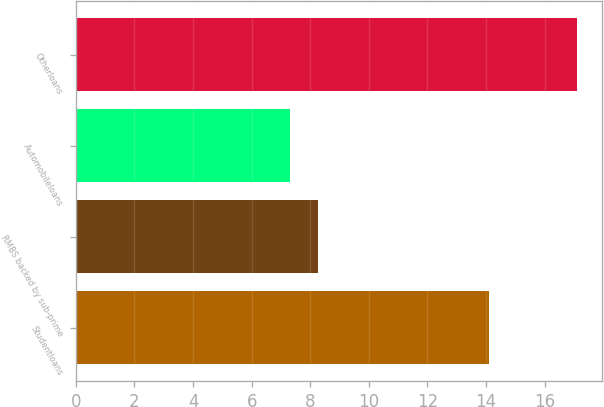Convert chart. <chart><loc_0><loc_0><loc_500><loc_500><bar_chart><fcel>Studentloans<fcel>RMBS backed by sub-prime<fcel>Automobileloans<fcel>Otherloans<nl><fcel>14.1<fcel>8.28<fcel>7.3<fcel>17.1<nl></chart> 